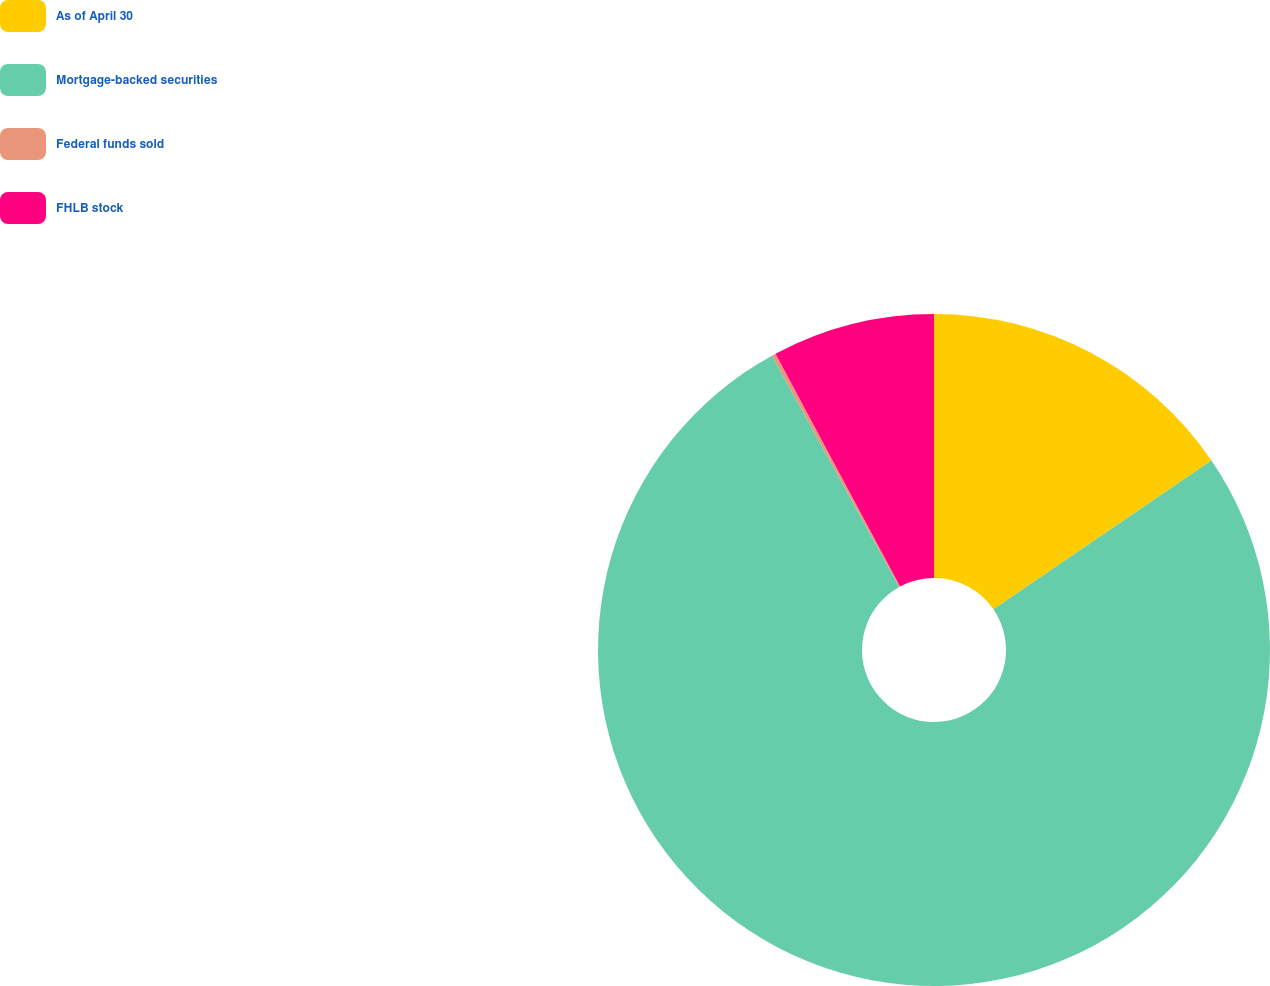Convert chart. <chart><loc_0><loc_0><loc_500><loc_500><pie_chart><fcel>As of April 30<fcel>Mortgage-backed securities<fcel>Federal funds sold<fcel>FHLB stock<nl><fcel>15.46%<fcel>76.54%<fcel>0.19%<fcel>7.82%<nl></chart> 